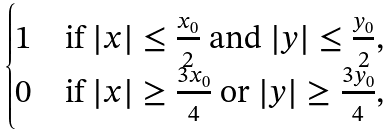<formula> <loc_0><loc_0><loc_500><loc_500>\begin{cases} 1 & \text {if $|x|\leq \frac{x_{0}}{2}$ and $|y|\leq \frac{y_{0}}{2}$} , \\ 0 & \text {if $|x|\geq \frac{3x_{0}}{4}$ or $|y|\geq \frac{3y_{0}}{4}$} , \end{cases}</formula> 